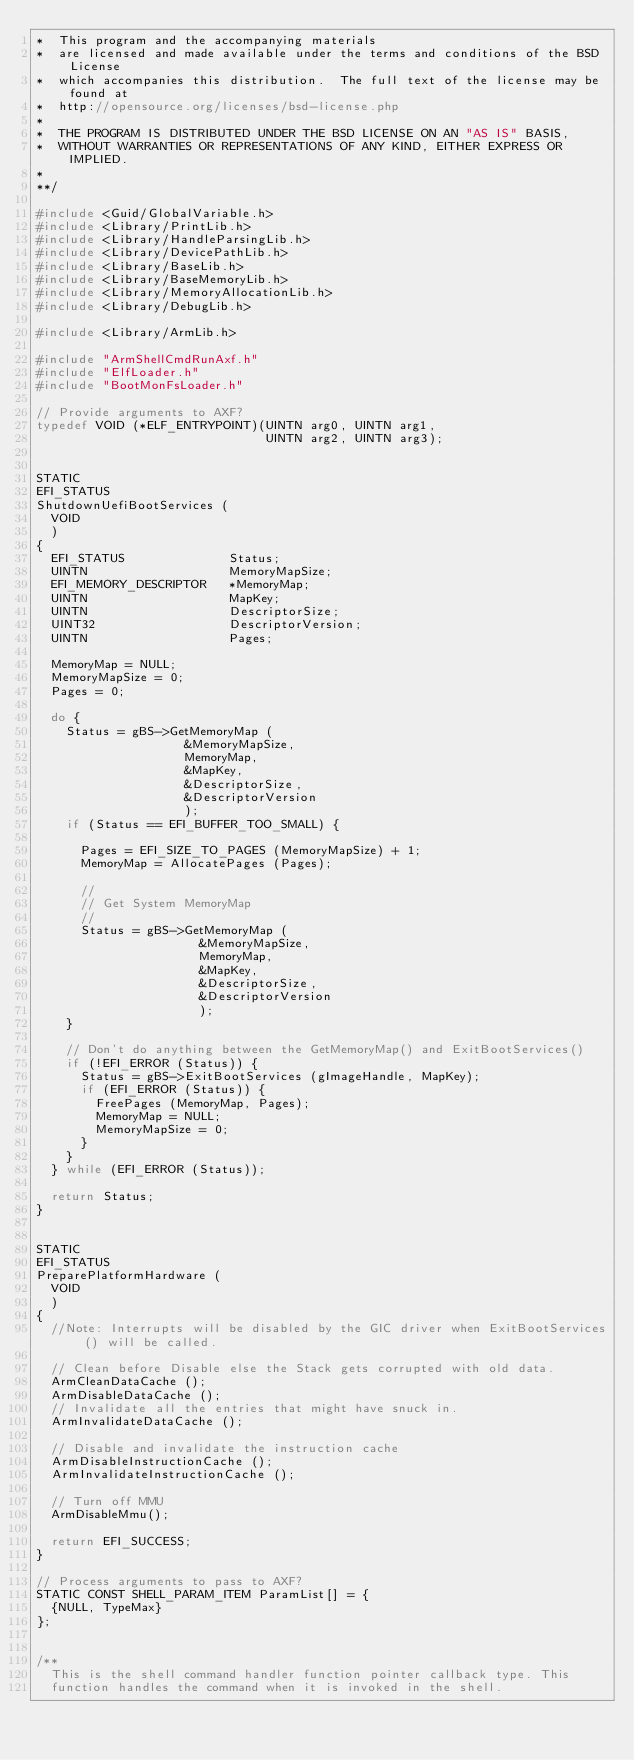Convert code to text. <code><loc_0><loc_0><loc_500><loc_500><_C_>*  This program and the accompanying materials
*  are licensed and made available under the terms and conditions of the BSD License
*  which accompanies this distribution.  The full text of the license may be found at
*  http://opensource.org/licenses/bsd-license.php
*
*  THE PROGRAM IS DISTRIBUTED UNDER THE BSD LICENSE ON AN "AS IS" BASIS,
*  WITHOUT WARRANTIES OR REPRESENTATIONS OF ANY KIND, EITHER EXPRESS OR IMPLIED.
*
**/

#include <Guid/GlobalVariable.h>
#include <Library/PrintLib.h>
#include <Library/HandleParsingLib.h>
#include <Library/DevicePathLib.h>
#include <Library/BaseLib.h>
#include <Library/BaseMemoryLib.h>
#include <Library/MemoryAllocationLib.h>
#include <Library/DebugLib.h>

#include <Library/ArmLib.h>

#include "ArmShellCmdRunAxf.h"
#include "ElfLoader.h"
#include "BootMonFsLoader.h"

// Provide arguments to AXF?
typedef VOID (*ELF_ENTRYPOINT)(UINTN arg0, UINTN arg1,
                               UINTN arg2, UINTN arg3);


STATIC
EFI_STATUS
ShutdownUefiBootServices (
  VOID
  )
{
  EFI_STATUS              Status;
  UINTN                   MemoryMapSize;
  EFI_MEMORY_DESCRIPTOR   *MemoryMap;
  UINTN                   MapKey;
  UINTN                   DescriptorSize;
  UINT32                  DescriptorVersion;
  UINTN                   Pages;

  MemoryMap = NULL;
  MemoryMapSize = 0;
  Pages = 0;

  do {
    Status = gBS->GetMemoryMap (
                    &MemoryMapSize,
                    MemoryMap,
                    &MapKey,
                    &DescriptorSize,
                    &DescriptorVersion
                    );
    if (Status == EFI_BUFFER_TOO_SMALL) {

      Pages = EFI_SIZE_TO_PAGES (MemoryMapSize) + 1;
      MemoryMap = AllocatePages (Pages);

      //
      // Get System MemoryMap
      //
      Status = gBS->GetMemoryMap (
                      &MemoryMapSize,
                      MemoryMap,
                      &MapKey,
                      &DescriptorSize,
                      &DescriptorVersion
                      );
    }

    // Don't do anything between the GetMemoryMap() and ExitBootServices()
    if (!EFI_ERROR (Status)) {
      Status = gBS->ExitBootServices (gImageHandle, MapKey);
      if (EFI_ERROR (Status)) {
        FreePages (MemoryMap, Pages);
        MemoryMap = NULL;
        MemoryMapSize = 0;
      }
    }
  } while (EFI_ERROR (Status));

  return Status;
}


STATIC
EFI_STATUS
PreparePlatformHardware (
  VOID
  )
{
  //Note: Interrupts will be disabled by the GIC driver when ExitBootServices() will be called.

  // Clean before Disable else the Stack gets corrupted with old data.
  ArmCleanDataCache ();
  ArmDisableDataCache ();
  // Invalidate all the entries that might have snuck in.
  ArmInvalidateDataCache ();

  // Disable and invalidate the instruction cache
  ArmDisableInstructionCache ();
  ArmInvalidateInstructionCache ();

  // Turn off MMU
  ArmDisableMmu();

  return EFI_SUCCESS;
}

// Process arguments to pass to AXF?
STATIC CONST SHELL_PARAM_ITEM ParamList[] = {
  {NULL, TypeMax}
};


/**
  This is the shell command handler function pointer callback type. This
  function handles the command when it is invoked in the shell.
</code> 